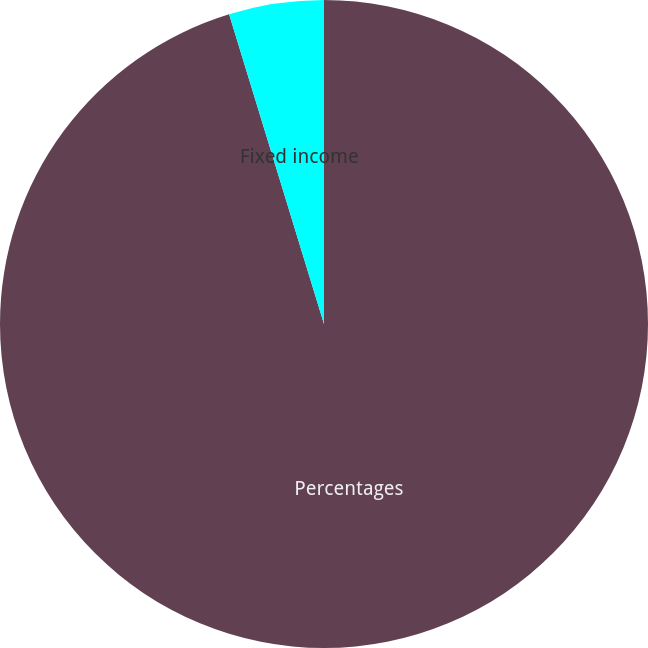<chart> <loc_0><loc_0><loc_500><loc_500><pie_chart><fcel>Percentages<fcel>Fixed income<nl><fcel>95.27%<fcel>4.73%<nl></chart> 